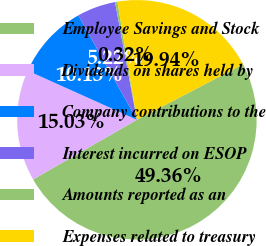Convert chart to OTSL. <chart><loc_0><loc_0><loc_500><loc_500><pie_chart><fcel>Employee Savings and Stock<fcel>Dividends on shares held by<fcel>Company contributions to the<fcel>Interest incurred on ESOP<fcel>Amounts reported as an<fcel>Expenses related to treasury<nl><fcel>49.36%<fcel>15.03%<fcel>10.13%<fcel>5.22%<fcel>0.32%<fcel>19.94%<nl></chart> 